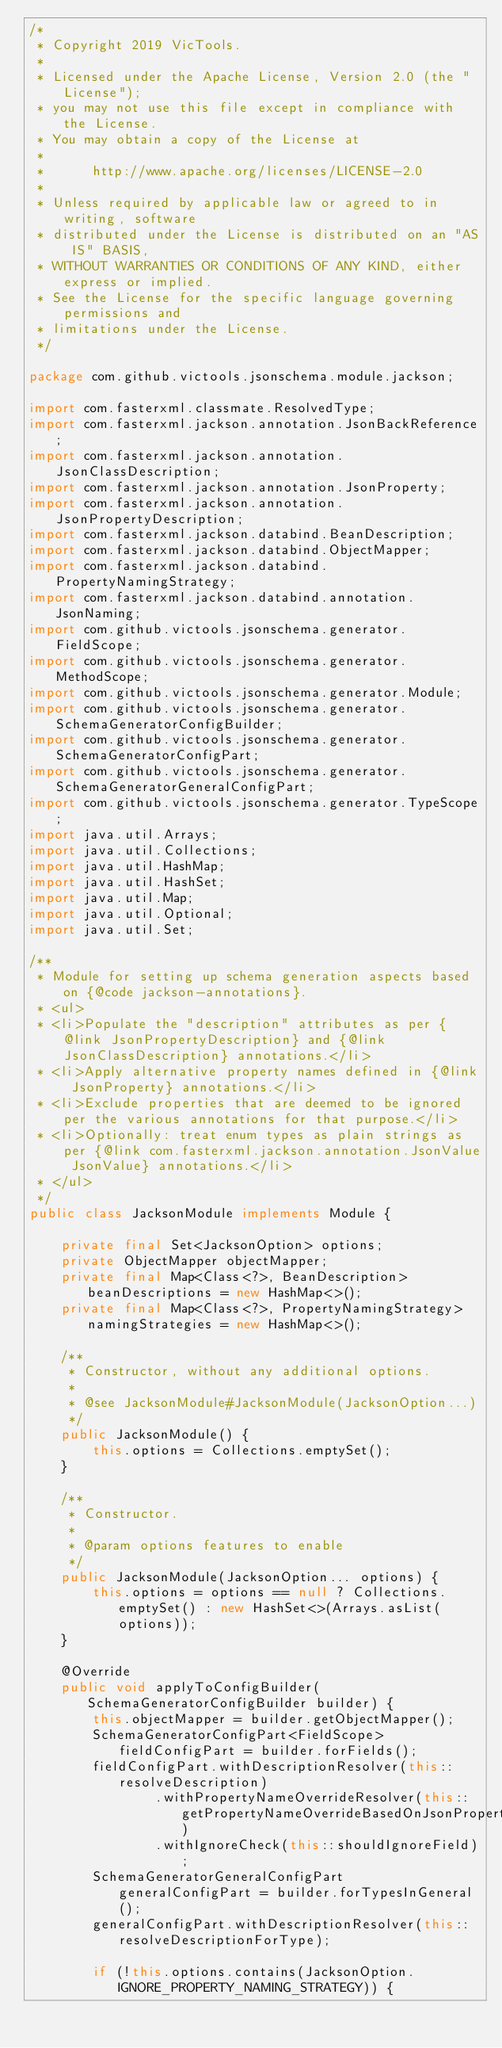<code> <loc_0><loc_0><loc_500><loc_500><_Java_>/*
 * Copyright 2019 VicTools.
 *
 * Licensed under the Apache License, Version 2.0 (the "License");
 * you may not use this file except in compliance with the License.
 * You may obtain a copy of the License at
 *
 *      http://www.apache.org/licenses/LICENSE-2.0
 *
 * Unless required by applicable law or agreed to in writing, software
 * distributed under the License is distributed on an "AS IS" BASIS,
 * WITHOUT WARRANTIES OR CONDITIONS OF ANY KIND, either express or implied.
 * See the License for the specific language governing permissions and
 * limitations under the License.
 */

package com.github.victools.jsonschema.module.jackson;

import com.fasterxml.classmate.ResolvedType;
import com.fasterxml.jackson.annotation.JsonBackReference;
import com.fasterxml.jackson.annotation.JsonClassDescription;
import com.fasterxml.jackson.annotation.JsonProperty;
import com.fasterxml.jackson.annotation.JsonPropertyDescription;
import com.fasterxml.jackson.databind.BeanDescription;
import com.fasterxml.jackson.databind.ObjectMapper;
import com.fasterxml.jackson.databind.PropertyNamingStrategy;
import com.fasterxml.jackson.databind.annotation.JsonNaming;
import com.github.victools.jsonschema.generator.FieldScope;
import com.github.victools.jsonschema.generator.MethodScope;
import com.github.victools.jsonschema.generator.Module;
import com.github.victools.jsonschema.generator.SchemaGeneratorConfigBuilder;
import com.github.victools.jsonschema.generator.SchemaGeneratorConfigPart;
import com.github.victools.jsonschema.generator.SchemaGeneratorGeneralConfigPart;
import com.github.victools.jsonschema.generator.TypeScope;
import java.util.Arrays;
import java.util.Collections;
import java.util.HashMap;
import java.util.HashSet;
import java.util.Map;
import java.util.Optional;
import java.util.Set;

/**
 * Module for setting up schema generation aspects based on {@code jackson-annotations}.
 * <ul>
 * <li>Populate the "description" attributes as per {@link JsonPropertyDescription} and {@link JsonClassDescription} annotations.</li>
 * <li>Apply alternative property names defined in {@link JsonProperty} annotations.</li>
 * <li>Exclude properties that are deemed to be ignored per the various annotations for that purpose.</li>
 * <li>Optionally: treat enum types as plain strings as per {@link com.fasterxml.jackson.annotation.JsonValue JsonValue} annotations.</li>
 * </ul>
 */
public class JacksonModule implements Module {

    private final Set<JacksonOption> options;
    private ObjectMapper objectMapper;
    private final Map<Class<?>, BeanDescription> beanDescriptions = new HashMap<>();
    private final Map<Class<?>, PropertyNamingStrategy> namingStrategies = new HashMap<>();

    /**
     * Constructor, without any additional options.
     *
     * @see JacksonModule#JacksonModule(JacksonOption...)
     */
    public JacksonModule() {
        this.options = Collections.emptySet();
    }

    /**
     * Constructor.
     *
     * @param options features to enable
     */
    public JacksonModule(JacksonOption... options) {
        this.options = options == null ? Collections.emptySet() : new HashSet<>(Arrays.asList(options));
    }

    @Override
    public void applyToConfigBuilder(SchemaGeneratorConfigBuilder builder) {
        this.objectMapper = builder.getObjectMapper();
        SchemaGeneratorConfigPart<FieldScope> fieldConfigPart = builder.forFields();
        fieldConfigPart.withDescriptionResolver(this::resolveDescription)
                .withPropertyNameOverrideResolver(this::getPropertyNameOverrideBasedOnJsonPropertyAnnotation)
                .withIgnoreCheck(this::shouldIgnoreField);
        SchemaGeneratorGeneralConfigPart generalConfigPart = builder.forTypesInGeneral();
        generalConfigPart.withDescriptionResolver(this::resolveDescriptionForType);

        if (!this.options.contains(JacksonOption.IGNORE_PROPERTY_NAMING_STRATEGY)) {</code> 